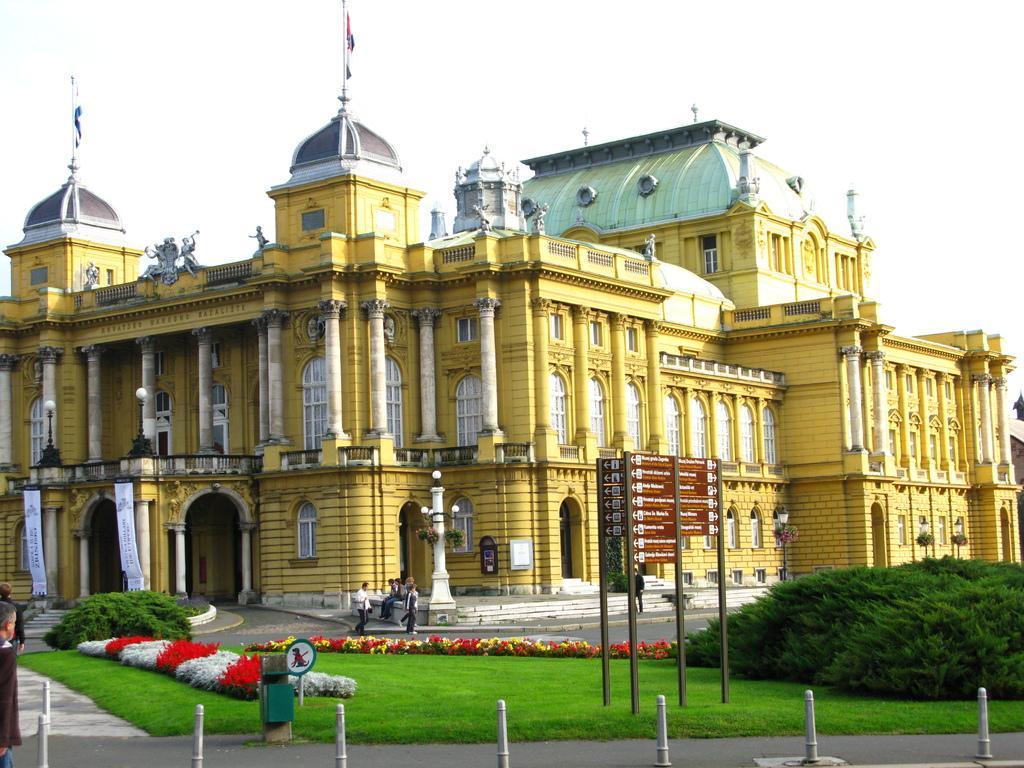In one or two sentences, can you explain what this image depicts? In this image, we can see a beautiful building with some flags on its tombs and in-front of the building we can see some people and in-front of the building there is a road and there is also some with some boarding's in the grass. 